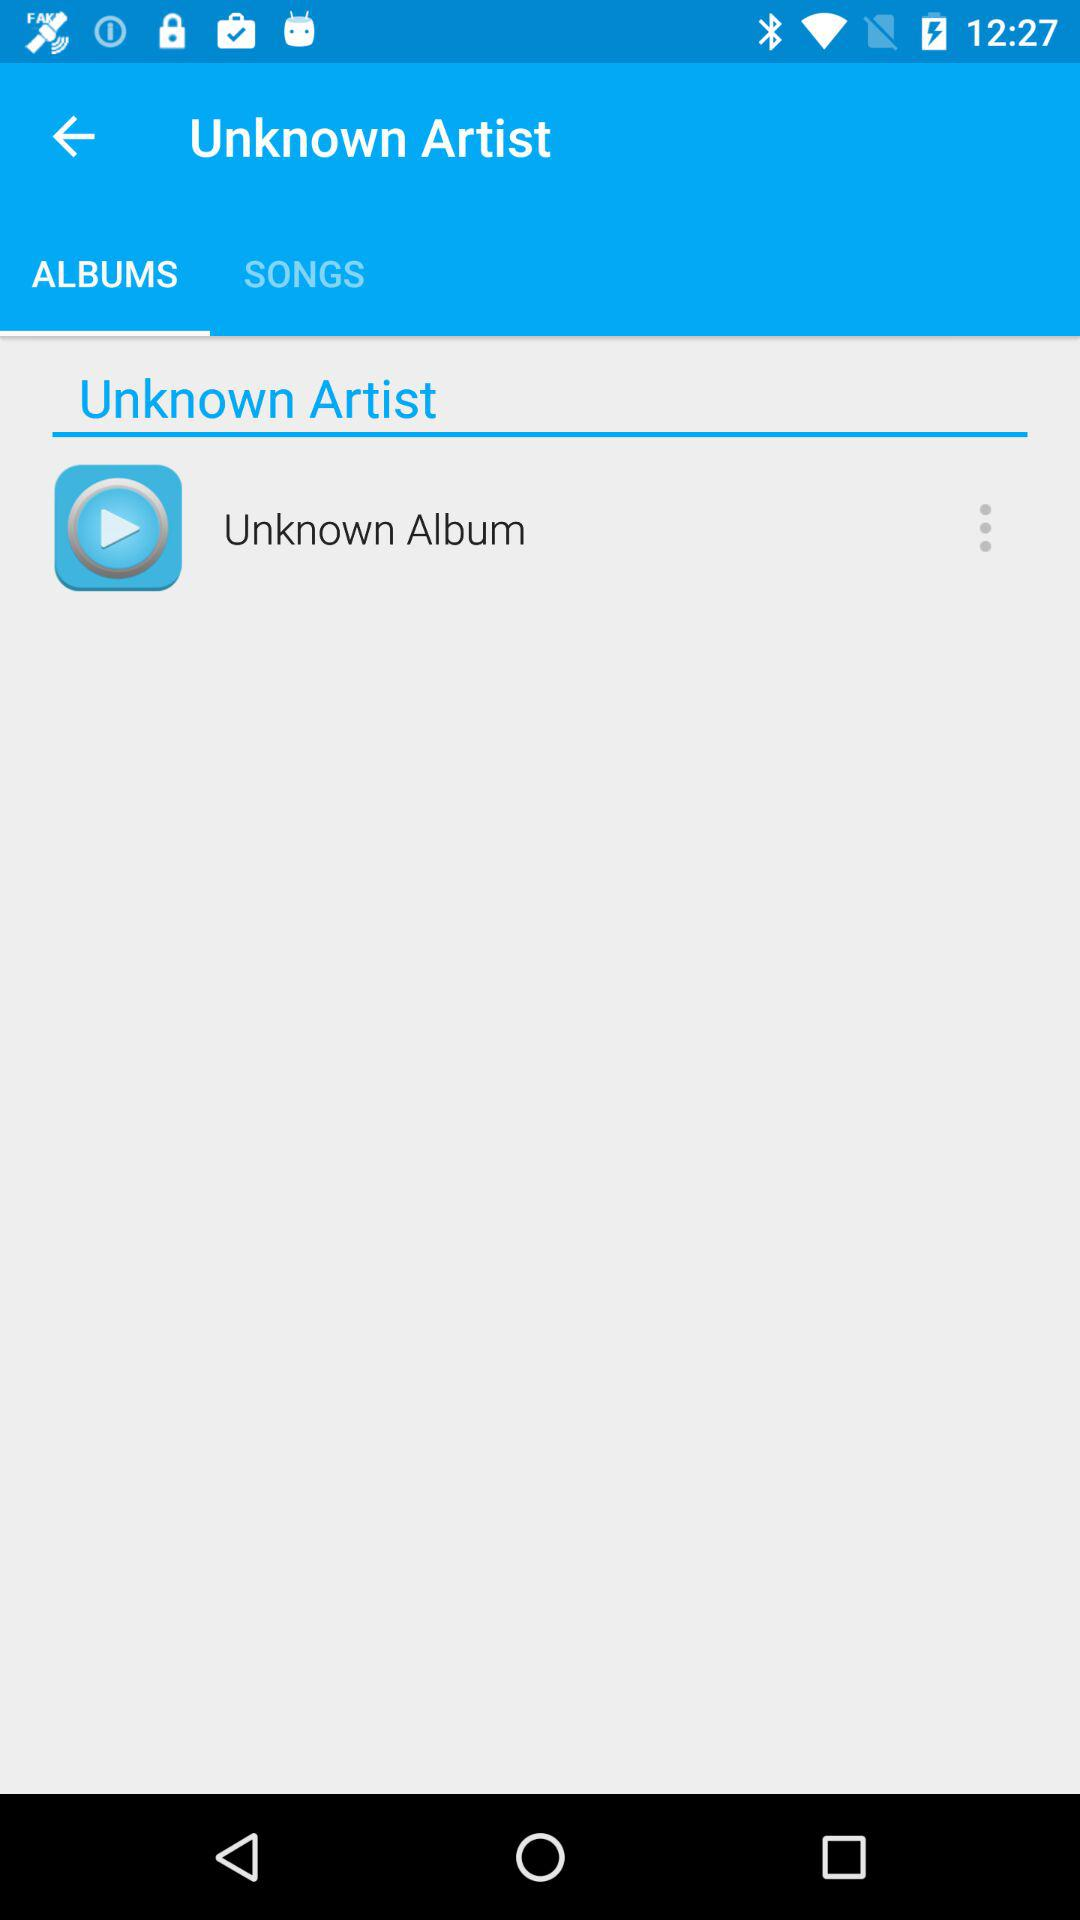What is the name of the song?
When the provided information is insufficient, respond with <no answer>. <no answer> 